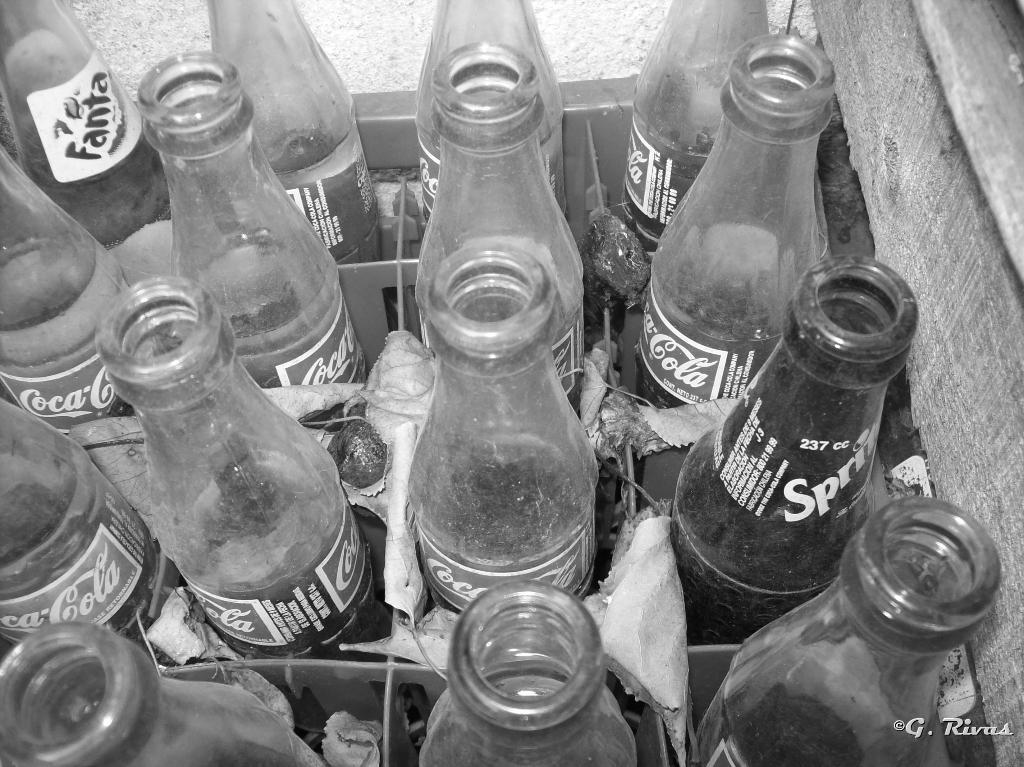How would you summarize this image in a sentence or two? This is the picture of a stand in which the bottles are arranged. 